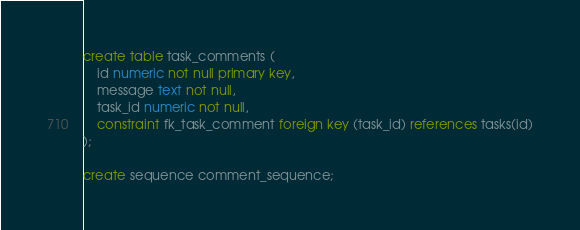<code> <loc_0><loc_0><loc_500><loc_500><_SQL_>create table task_comments (
    id numeric not null primary key,
    message text not null,
    task_id numeric not null,
    constraint fk_task_comment foreign key (task_id) references tasks(id)
);

create sequence comment_sequence;</code> 